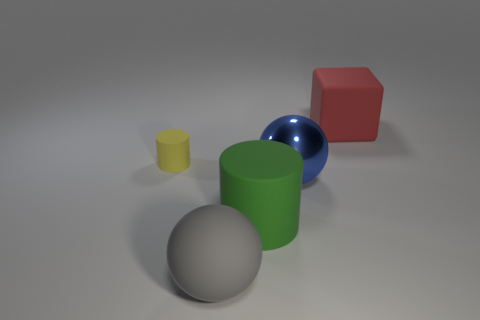Add 1 blue matte blocks. How many objects exist? 6 Subtract all gray balls. How many balls are left? 1 Subtract all small yellow matte things. Subtract all matte cubes. How many objects are left? 3 Add 1 big cubes. How many big cubes are left? 2 Add 5 large brown rubber spheres. How many large brown rubber spheres exist? 5 Subtract 1 green cylinders. How many objects are left? 4 Subtract all cylinders. How many objects are left? 3 Subtract 1 blocks. How many blocks are left? 0 Subtract all cyan cylinders. Subtract all purple balls. How many cylinders are left? 2 